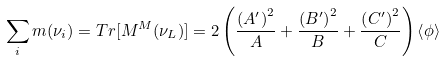Convert formula to latex. <formula><loc_0><loc_0><loc_500><loc_500>\sum _ { i } m ( \nu _ { i } ) = { T r } [ M ^ { M } ( \nu _ { L } ) ] = 2 \left ( \frac { \left ( A ^ { \prime } \right ) ^ { 2 } } { A } + \frac { \left ( B ^ { \prime } \right ) ^ { 2 } } { B } + \frac { \left ( C ^ { \prime } \right ) ^ { 2 } } { C } \right ) \left \langle \phi \right \rangle</formula> 